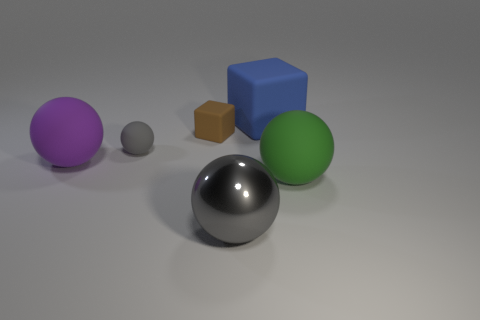Subtract all big purple balls. How many balls are left? 3 Add 3 big gray shiny cylinders. How many objects exist? 9 Subtract all blue cubes. How many cubes are left? 1 Subtract all balls. How many objects are left? 2 Add 2 big blue rubber blocks. How many big blue rubber blocks are left? 3 Add 3 big gray metal spheres. How many big gray metal spheres exist? 4 Subtract 1 gray balls. How many objects are left? 5 Subtract 1 spheres. How many spheres are left? 3 Subtract all blue blocks. Subtract all green balls. How many blocks are left? 1 Subtract all blue cylinders. How many gray spheres are left? 2 